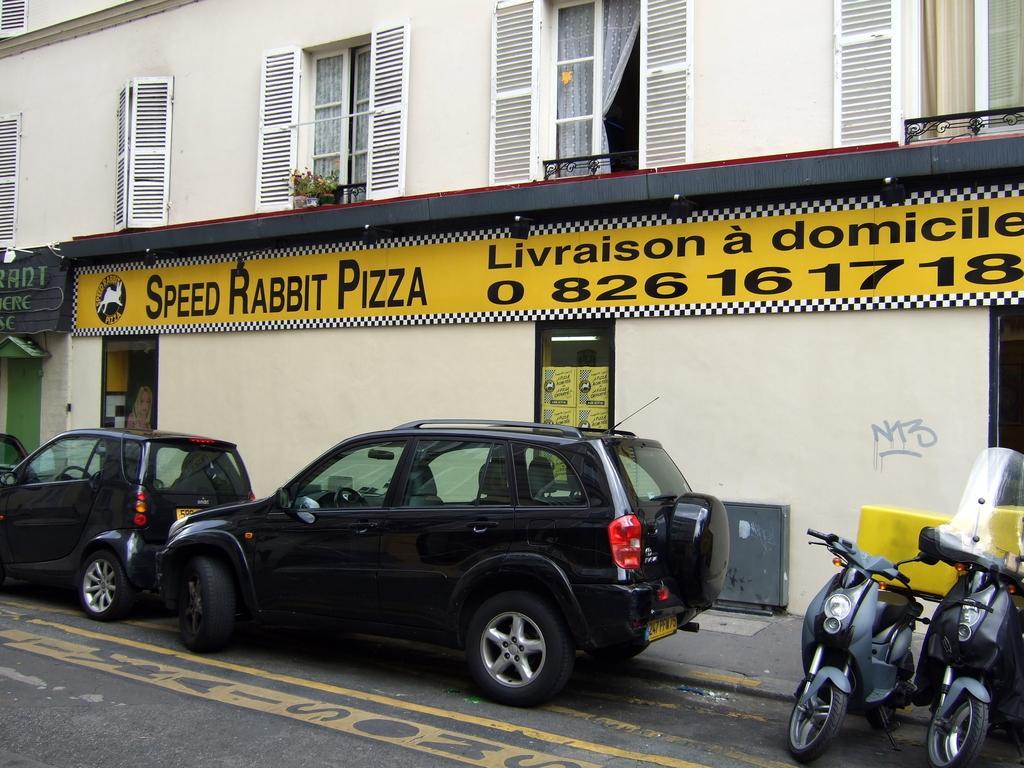Describe this image in one or two sentences. In this image at front there are vehicles parked on the road. At the back side there is a building. 